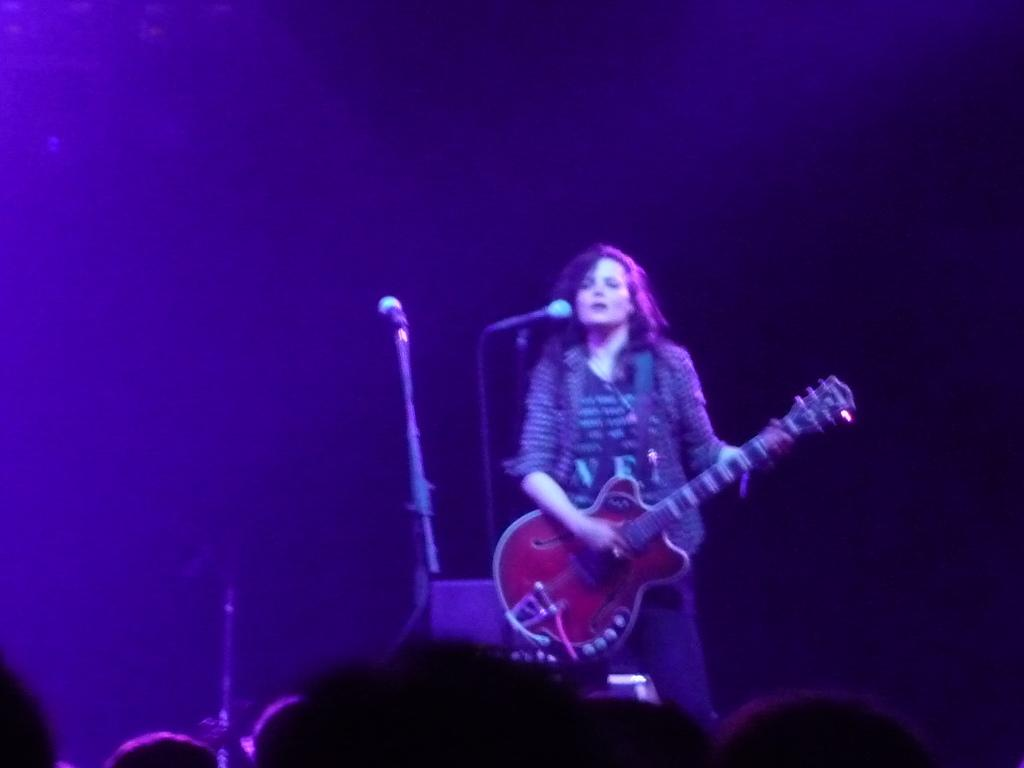What is the main subject of the image? The main subject of the image is a woman. What is the woman holding in the image? The woman is holding a guitar. What other object can be seen in the image? There is a microphone (mic) in the image. What type of doctor is standing next to the woman in the image? There is no doctor present in the image. What type of coil is visible in the image? There is no coil visible in the image. 